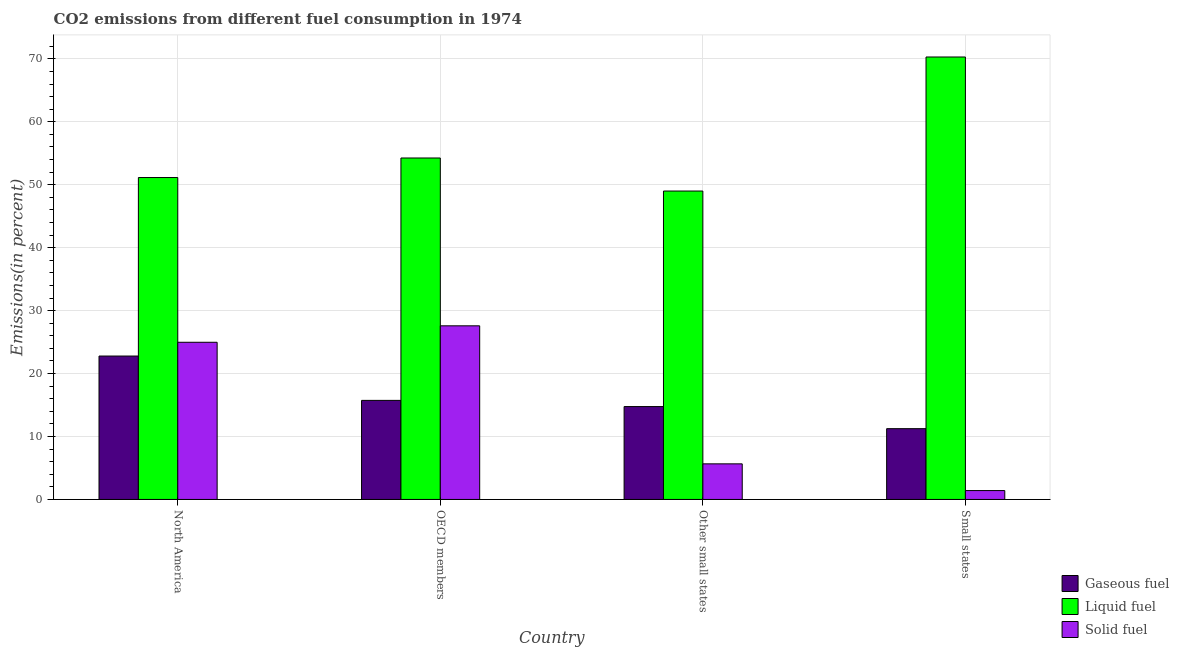How many groups of bars are there?
Give a very brief answer. 4. Are the number of bars per tick equal to the number of legend labels?
Provide a short and direct response. Yes. What is the label of the 3rd group of bars from the left?
Provide a succinct answer. Other small states. In how many cases, is the number of bars for a given country not equal to the number of legend labels?
Ensure brevity in your answer.  0. What is the percentage of gaseous fuel emission in North America?
Give a very brief answer. 22.78. Across all countries, what is the maximum percentage of solid fuel emission?
Provide a short and direct response. 27.58. Across all countries, what is the minimum percentage of gaseous fuel emission?
Provide a short and direct response. 11.25. In which country was the percentage of gaseous fuel emission maximum?
Offer a terse response. North America. In which country was the percentage of gaseous fuel emission minimum?
Your response must be concise. Small states. What is the total percentage of gaseous fuel emission in the graph?
Your answer should be compact. 64.52. What is the difference between the percentage of gaseous fuel emission in North America and that in Other small states?
Provide a succinct answer. 8.03. What is the difference between the percentage of solid fuel emission in OECD members and the percentage of liquid fuel emission in North America?
Your response must be concise. -23.56. What is the average percentage of solid fuel emission per country?
Your answer should be compact. 14.91. What is the difference between the percentage of gaseous fuel emission and percentage of solid fuel emission in OECD members?
Your answer should be compact. -11.85. In how many countries, is the percentage of liquid fuel emission greater than 46 %?
Your answer should be very brief. 4. What is the ratio of the percentage of gaseous fuel emission in North America to that in Small states?
Offer a very short reply. 2.03. Is the percentage of gaseous fuel emission in OECD members less than that in Small states?
Offer a terse response. No. What is the difference between the highest and the second highest percentage of gaseous fuel emission?
Give a very brief answer. 7.04. What is the difference between the highest and the lowest percentage of liquid fuel emission?
Give a very brief answer. 21.29. In how many countries, is the percentage of gaseous fuel emission greater than the average percentage of gaseous fuel emission taken over all countries?
Offer a very short reply. 1. Is the sum of the percentage of solid fuel emission in OECD members and Small states greater than the maximum percentage of gaseous fuel emission across all countries?
Your response must be concise. Yes. What does the 2nd bar from the left in North America represents?
Provide a short and direct response. Liquid fuel. What does the 2nd bar from the right in Small states represents?
Offer a terse response. Liquid fuel. Is it the case that in every country, the sum of the percentage of gaseous fuel emission and percentage of liquid fuel emission is greater than the percentage of solid fuel emission?
Ensure brevity in your answer.  Yes. Are the values on the major ticks of Y-axis written in scientific E-notation?
Your response must be concise. No. Does the graph contain any zero values?
Ensure brevity in your answer.  No. Where does the legend appear in the graph?
Make the answer very short. Bottom right. What is the title of the graph?
Offer a very short reply. CO2 emissions from different fuel consumption in 1974. What is the label or title of the Y-axis?
Make the answer very short. Emissions(in percent). What is the Emissions(in percent) of Gaseous fuel in North America?
Your answer should be very brief. 22.78. What is the Emissions(in percent) of Liquid fuel in North America?
Your answer should be very brief. 51.14. What is the Emissions(in percent) of Solid fuel in North America?
Make the answer very short. 24.97. What is the Emissions(in percent) in Gaseous fuel in OECD members?
Offer a terse response. 15.74. What is the Emissions(in percent) in Liquid fuel in OECD members?
Keep it short and to the point. 54.25. What is the Emissions(in percent) of Solid fuel in OECD members?
Your answer should be compact. 27.58. What is the Emissions(in percent) of Gaseous fuel in Other small states?
Offer a terse response. 14.76. What is the Emissions(in percent) of Liquid fuel in Other small states?
Provide a succinct answer. 49. What is the Emissions(in percent) of Solid fuel in Other small states?
Provide a short and direct response. 5.66. What is the Emissions(in percent) in Gaseous fuel in Small states?
Provide a short and direct response. 11.25. What is the Emissions(in percent) in Liquid fuel in Small states?
Offer a very short reply. 70.29. What is the Emissions(in percent) of Solid fuel in Small states?
Your answer should be compact. 1.41. Across all countries, what is the maximum Emissions(in percent) in Gaseous fuel?
Offer a very short reply. 22.78. Across all countries, what is the maximum Emissions(in percent) in Liquid fuel?
Offer a terse response. 70.29. Across all countries, what is the maximum Emissions(in percent) of Solid fuel?
Give a very brief answer. 27.58. Across all countries, what is the minimum Emissions(in percent) of Gaseous fuel?
Provide a short and direct response. 11.25. Across all countries, what is the minimum Emissions(in percent) in Liquid fuel?
Offer a terse response. 49. Across all countries, what is the minimum Emissions(in percent) in Solid fuel?
Provide a short and direct response. 1.41. What is the total Emissions(in percent) in Gaseous fuel in the graph?
Ensure brevity in your answer.  64.52. What is the total Emissions(in percent) of Liquid fuel in the graph?
Offer a terse response. 224.68. What is the total Emissions(in percent) of Solid fuel in the graph?
Keep it short and to the point. 59.62. What is the difference between the Emissions(in percent) in Gaseous fuel in North America and that in OECD members?
Your answer should be compact. 7.04. What is the difference between the Emissions(in percent) in Liquid fuel in North America and that in OECD members?
Provide a short and direct response. -3.11. What is the difference between the Emissions(in percent) in Solid fuel in North America and that in OECD members?
Provide a succinct answer. -2.61. What is the difference between the Emissions(in percent) of Gaseous fuel in North America and that in Other small states?
Keep it short and to the point. 8.03. What is the difference between the Emissions(in percent) in Liquid fuel in North America and that in Other small states?
Keep it short and to the point. 2.14. What is the difference between the Emissions(in percent) of Solid fuel in North America and that in Other small states?
Make the answer very short. 19.32. What is the difference between the Emissions(in percent) of Gaseous fuel in North America and that in Small states?
Your answer should be very brief. 11.54. What is the difference between the Emissions(in percent) in Liquid fuel in North America and that in Small states?
Your answer should be very brief. -19.15. What is the difference between the Emissions(in percent) in Solid fuel in North America and that in Small states?
Give a very brief answer. 23.56. What is the difference between the Emissions(in percent) of Gaseous fuel in OECD members and that in Other small states?
Provide a short and direct response. 0.98. What is the difference between the Emissions(in percent) in Liquid fuel in OECD members and that in Other small states?
Provide a short and direct response. 5.25. What is the difference between the Emissions(in percent) in Solid fuel in OECD members and that in Other small states?
Your answer should be compact. 21.93. What is the difference between the Emissions(in percent) in Gaseous fuel in OECD members and that in Small states?
Offer a terse response. 4.49. What is the difference between the Emissions(in percent) in Liquid fuel in OECD members and that in Small states?
Give a very brief answer. -16.04. What is the difference between the Emissions(in percent) of Solid fuel in OECD members and that in Small states?
Your response must be concise. 26.17. What is the difference between the Emissions(in percent) of Gaseous fuel in Other small states and that in Small states?
Provide a short and direct response. 3.51. What is the difference between the Emissions(in percent) of Liquid fuel in Other small states and that in Small states?
Your answer should be compact. -21.29. What is the difference between the Emissions(in percent) in Solid fuel in Other small states and that in Small states?
Keep it short and to the point. 4.25. What is the difference between the Emissions(in percent) of Gaseous fuel in North America and the Emissions(in percent) of Liquid fuel in OECD members?
Keep it short and to the point. -31.47. What is the difference between the Emissions(in percent) of Gaseous fuel in North America and the Emissions(in percent) of Solid fuel in OECD members?
Offer a very short reply. -4.8. What is the difference between the Emissions(in percent) of Liquid fuel in North America and the Emissions(in percent) of Solid fuel in OECD members?
Your answer should be very brief. 23.56. What is the difference between the Emissions(in percent) in Gaseous fuel in North America and the Emissions(in percent) in Liquid fuel in Other small states?
Ensure brevity in your answer.  -26.21. What is the difference between the Emissions(in percent) of Gaseous fuel in North America and the Emissions(in percent) of Solid fuel in Other small states?
Offer a terse response. 17.13. What is the difference between the Emissions(in percent) in Liquid fuel in North America and the Emissions(in percent) in Solid fuel in Other small states?
Offer a terse response. 45.49. What is the difference between the Emissions(in percent) of Gaseous fuel in North America and the Emissions(in percent) of Liquid fuel in Small states?
Give a very brief answer. -47.51. What is the difference between the Emissions(in percent) in Gaseous fuel in North America and the Emissions(in percent) in Solid fuel in Small states?
Make the answer very short. 21.37. What is the difference between the Emissions(in percent) of Liquid fuel in North America and the Emissions(in percent) of Solid fuel in Small states?
Offer a very short reply. 49.73. What is the difference between the Emissions(in percent) in Gaseous fuel in OECD members and the Emissions(in percent) in Liquid fuel in Other small states?
Make the answer very short. -33.26. What is the difference between the Emissions(in percent) in Gaseous fuel in OECD members and the Emissions(in percent) in Solid fuel in Other small states?
Your answer should be very brief. 10.08. What is the difference between the Emissions(in percent) of Liquid fuel in OECD members and the Emissions(in percent) of Solid fuel in Other small states?
Ensure brevity in your answer.  48.59. What is the difference between the Emissions(in percent) in Gaseous fuel in OECD members and the Emissions(in percent) in Liquid fuel in Small states?
Your answer should be very brief. -54.55. What is the difference between the Emissions(in percent) of Gaseous fuel in OECD members and the Emissions(in percent) of Solid fuel in Small states?
Give a very brief answer. 14.33. What is the difference between the Emissions(in percent) in Liquid fuel in OECD members and the Emissions(in percent) in Solid fuel in Small states?
Keep it short and to the point. 52.84. What is the difference between the Emissions(in percent) of Gaseous fuel in Other small states and the Emissions(in percent) of Liquid fuel in Small states?
Offer a terse response. -55.54. What is the difference between the Emissions(in percent) of Gaseous fuel in Other small states and the Emissions(in percent) of Solid fuel in Small states?
Keep it short and to the point. 13.35. What is the difference between the Emissions(in percent) of Liquid fuel in Other small states and the Emissions(in percent) of Solid fuel in Small states?
Ensure brevity in your answer.  47.59. What is the average Emissions(in percent) of Gaseous fuel per country?
Provide a short and direct response. 16.13. What is the average Emissions(in percent) of Liquid fuel per country?
Ensure brevity in your answer.  56.17. What is the average Emissions(in percent) of Solid fuel per country?
Your answer should be very brief. 14.91. What is the difference between the Emissions(in percent) of Gaseous fuel and Emissions(in percent) of Liquid fuel in North America?
Offer a very short reply. -28.36. What is the difference between the Emissions(in percent) in Gaseous fuel and Emissions(in percent) in Solid fuel in North America?
Provide a short and direct response. -2.19. What is the difference between the Emissions(in percent) of Liquid fuel and Emissions(in percent) of Solid fuel in North America?
Make the answer very short. 26.17. What is the difference between the Emissions(in percent) of Gaseous fuel and Emissions(in percent) of Liquid fuel in OECD members?
Your response must be concise. -38.51. What is the difference between the Emissions(in percent) of Gaseous fuel and Emissions(in percent) of Solid fuel in OECD members?
Keep it short and to the point. -11.85. What is the difference between the Emissions(in percent) of Liquid fuel and Emissions(in percent) of Solid fuel in OECD members?
Offer a very short reply. 26.66. What is the difference between the Emissions(in percent) in Gaseous fuel and Emissions(in percent) in Liquid fuel in Other small states?
Provide a succinct answer. -34.24. What is the difference between the Emissions(in percent) in Gaseous fuel and Emissions(in percent) in Solid fuel in Other small states?
Make the answer very short. 9.1. What is the difference between the Emissions(in percent) in Liquid fuel and Emissions(in percent) in Solid fuel in Other small states?
Give a very brief answer. 43.34. What is the difference between the Emissions(in percent) in Gaseous fuel and Emissions(in percent) in Liquid fuel in Small states?
Offer a very short reply. -59.05. What is the difference between the Emissions(in percent) in Gaseous fuel and Emissions(in percent) in Solid fuel in Small states?
Your answer should be very brief. 9.83. What is the difference between the Emissions(in percent) in Liquid fuel and Emissions(in percent) in Solid fuel in Small states?
Provide a succinct answer. 68.88. What is the ratio of the Emissions(in percent) in Gaseous fuel in North America to that in OECD members?
Provide a short and direct response. 1.45. What is the ratio of the Emissions(in percent) in Liquid fuel in North America to that in OECD members?
Your answer should be compact. 0.94. What is the ratio of the Emissions(in percent) in Solid fuel in North America to that in OECD members?
Provide a short and direct response. 0.91. What is the ratio of the Emissions(in percent) in Gaseous fuel in North America to that in Other small states?
Make the answer very short. 1.54. What is the ratio of the Emissions(in percent) of Liquid fuel in North America to that in Other small states?
Offer a very short reply. 1.04. What is the ratio of the Emissions(in percent) in Solid fuel in North America to that in Other small states?
Provide a short and direct response. 4.42. What is the ratio of the Emissions(in percent) of Gaseous fuel in North America to that in Small states?
Keep it short and to the point. 2.03. What is the ratio of the Emissions(in percent) in Liquid fuel in North America to that in Small states?
Provide a short and direct response. 0.73. What is the ratio of the Emissions(in percent) of Solid fuel in North America to that in Small states?
Offer a very short reply. 17.7. What is the ratio of the Emissions(in percent) in Gaseous fuel in OECD members to that in Other small states?
Make the answer very short. 1.07. What is the ratio of the Emissions(in percent) in Liquid fuel in OECD members to that in Other small states?
Your answer should be very brief. 1.11. What is the ratio of the Emissions(in percent) in Solid fuel in OECD members to that in Other small states?
Keep it short and to the point. 4.88. What is the ratio of the Emissions(in percent) in Gaseous fuel in OECD members to that in Small states?
Provide a short and direct response. 1.4. What is the ratio of the Emissions(in percent) in Liquid fuel in OECD members to that in Small states?
Give a very brief answer. 0.77. What is the ratio of the Emissions(in percent) of Solid fuel in OECD members to that in Small states?
Keep it short and to the point. 19.56. What is the ratio of the Emissions(in percent) in Gaseous fuel in Other small states to that in Small states?
Your answer should be compact. 1.31. What is the ratio of the Emissions(in percent) in Liquid fuel in Other small states to that in Small states?
Offer a terse response. 0.7. What is the ratio of the Emissions(in percent) of Solid fuel in Other small states to that in Small states?
Give a very brief answer. 4.01. What is the difference between the highest and the second highest Emissions(in percent) in Gaseous fuel?
Give a very brief answer. 7.04. What is the difference between the highest and the second highest Emissions(in percent) in Liquid fuel?
Your answer should be compact. 16.04. What is the difference between the highest and the second highest Emissions(in percent) of Solid fuel?
Provide a short and direct response. 2.61. What is the difference between the highest and the lowest Emissions(in percent) in Gaseous fuel?
Provide a succinct answer. 11.54. What is the difference between the highest and the lowest Emissions(in percent) in Liquid fuel?
Make the answer very short. 21.29. What is the difference between the highest and the lowest Emissions(in percent) of Solid fuel?
Provide a short and direct response. 26.17. 